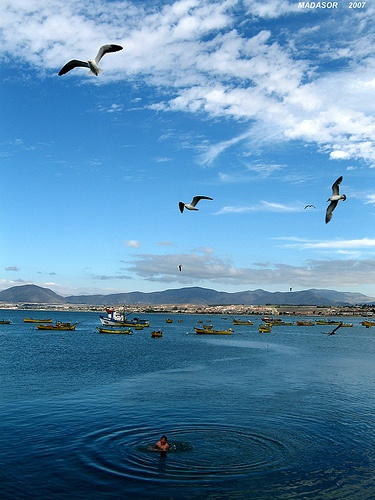Describe the objects in this image and their specific colors. I can see boat in lavender, lightblue, teal, and blue tones, bird in lavender, black, lightgray, darkgray, and gray tones, bird in lavender, black, lightblue, and gray tones, boat in lavender, black, navy, gray, and darkgray tones, and boat in lavender, black, olive, maroon, and blue tones in this image. 